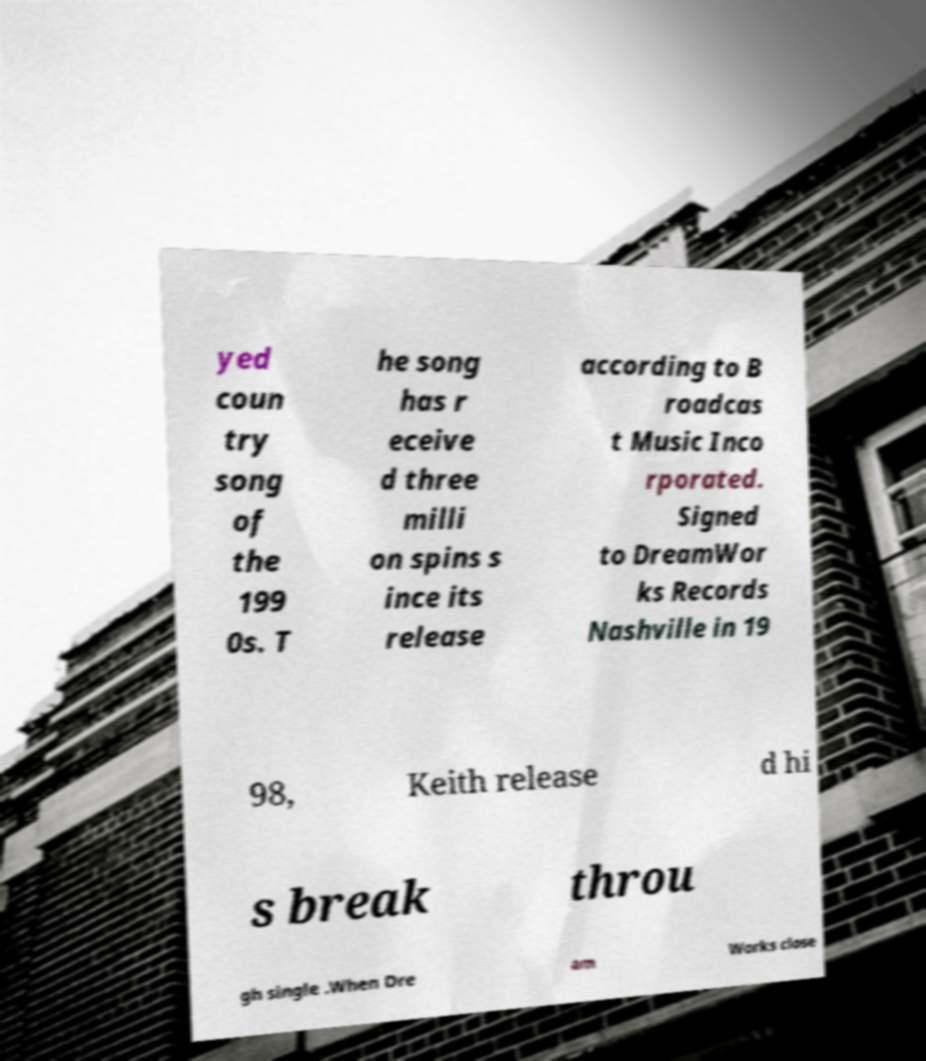What messages or text are displayed in this image? I need them in a readable, typed format. yed coun try song of the 199 0s. T he song has r eceive d three milli on spins s ince its release according to B roadcas t Music Inco rporated. Signed to DreamWor ks Records Nashville in 19 98, Keith release d hi s break throu gh single .When Dre am Works close 